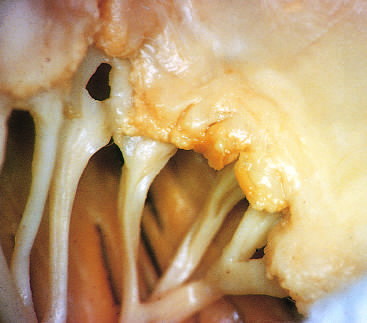what have previous episodes of rheumatic valvulitis caused?
Answer the question using a single word or phrase. Fibrous thickening and fusion of the chordae tendineae 